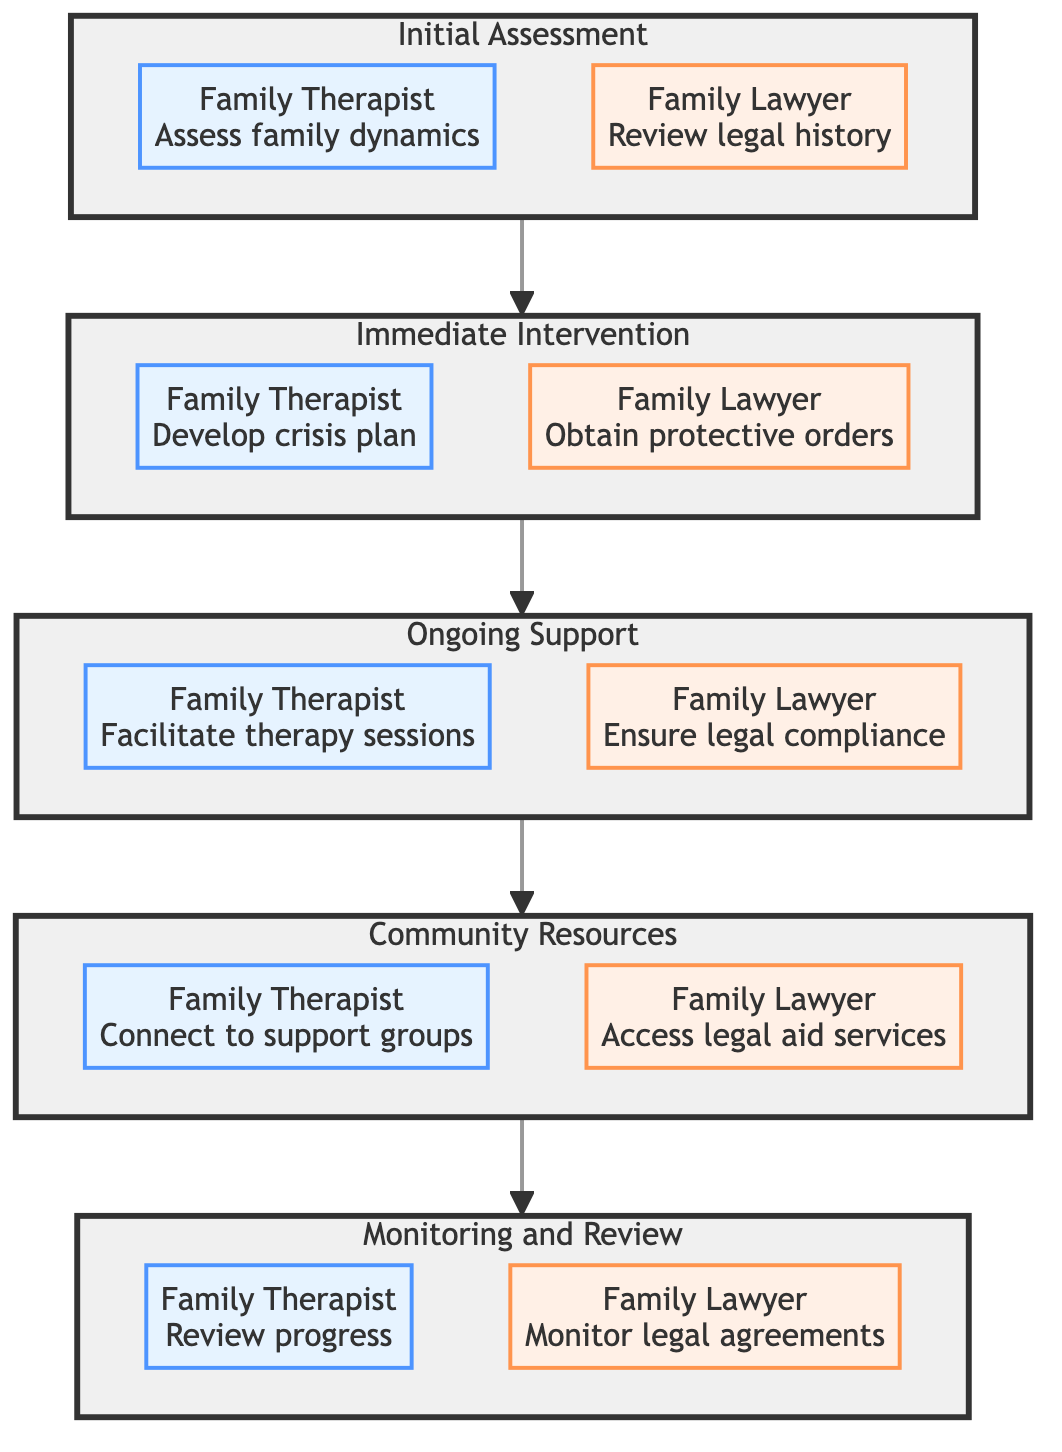What are the two main roles identified in the diagram? The diagram identifies the roles of the Family Therapist and the Family Lawyer, which are consistent across all phases of the clinical pathway.
Answer: Family Therapist, Family Lawyer How many phases are depicted in the diagram? There are five distinct phases illustrated in the diagram: Initial Assessment, Immediate Intervention, Ongoing Support, Community Resources, and Monitoring and Review.
Answer: Five What is the first intervention for the Family Therapist? The first intervention for the Family Therapist, as shown in the Initial Assessment phase, is to conduct comprehensive family interviews.
Answer: Conduct comprehensive family interviews Which phase includes the action of obtaining emergency protective orders? The action of obtaining emergency protective orders is included in the Immediate Intervention phase, specifically by the Family Lawyer.
Answer: Immediate Intervention What does the Family Therapist provide during the Monitoring and Review phase? During the Monitoring and Review phase, the Family Therapist regularly reviews progress with the family and adjusts treatment plans.
Answer: Regularly review progress How does the diagram illustrate the progression of the process? The diagram illustrates progression using a linear flow that connects each phase in sequence from Initial Assessment to Monitoring and Review, emphasizing the order of operations.
Answer: Linear flow Which action is common to both the Family Therapist and Family Lawyer in the Ongoing Support phase? In the Ongoing Support phase, both the Family Therapist and the Family Lawyer engage in actions that ensure continuity of support, specifically related to legal compliance and therapy sessions.
Answer: Ensure legal compliance, Facilitate therapy sessions What kind of connections does the diagram represent? The diagram represents connections through phases where each phase leads to the next, indicating a structured clinical pathway for providing support for families dealing with substance abuse.
Answer: Structured clinical pathway 